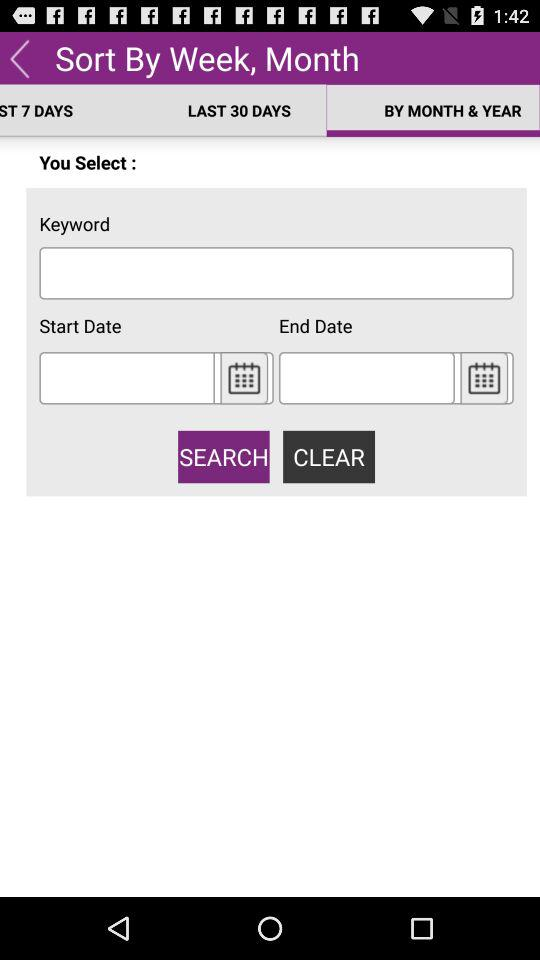How many more days are in the last 30 days than the ST 7 days?
Answer the question using a single word or phrase. 23 